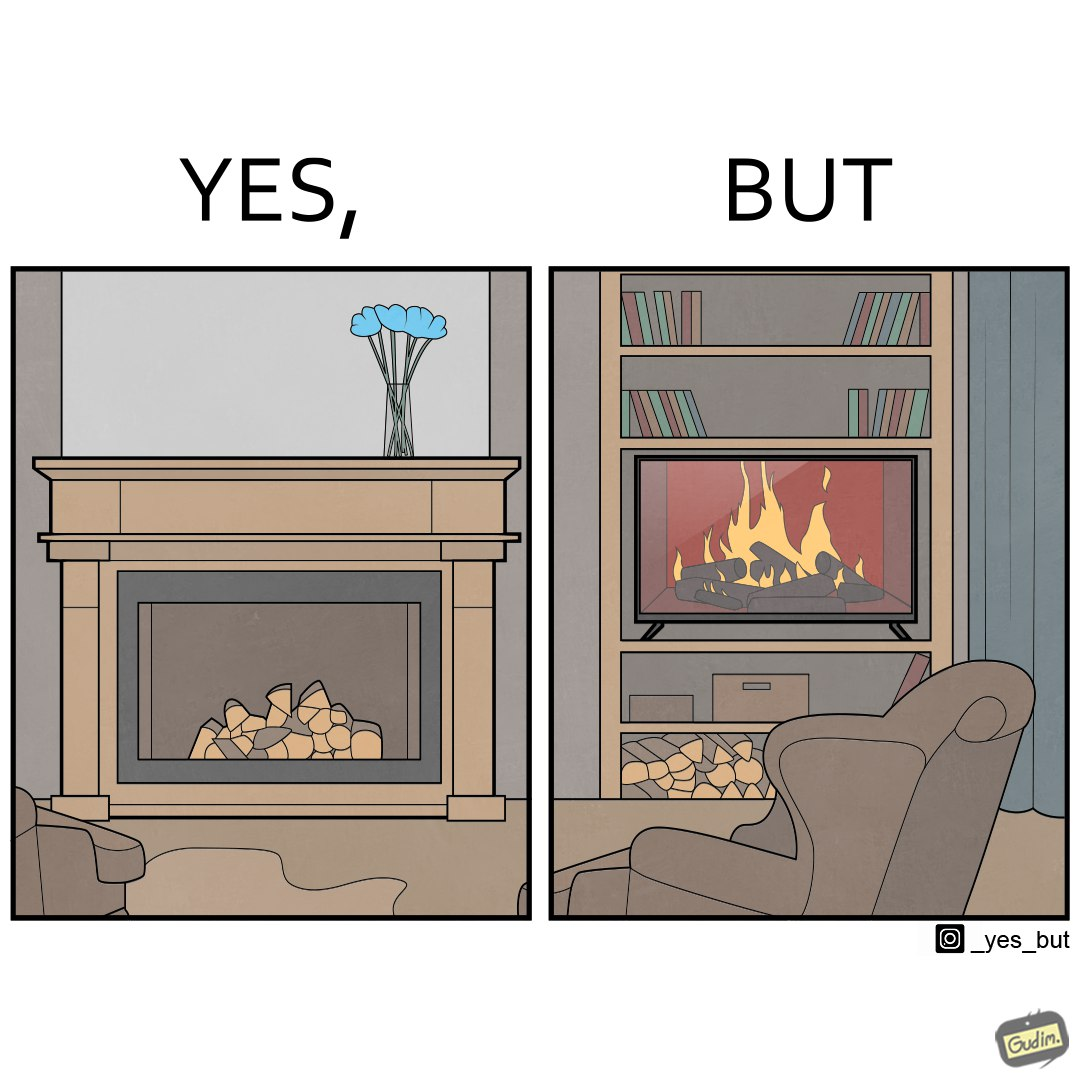Does this image contain satire or humor? Yes, this image is satirical. 